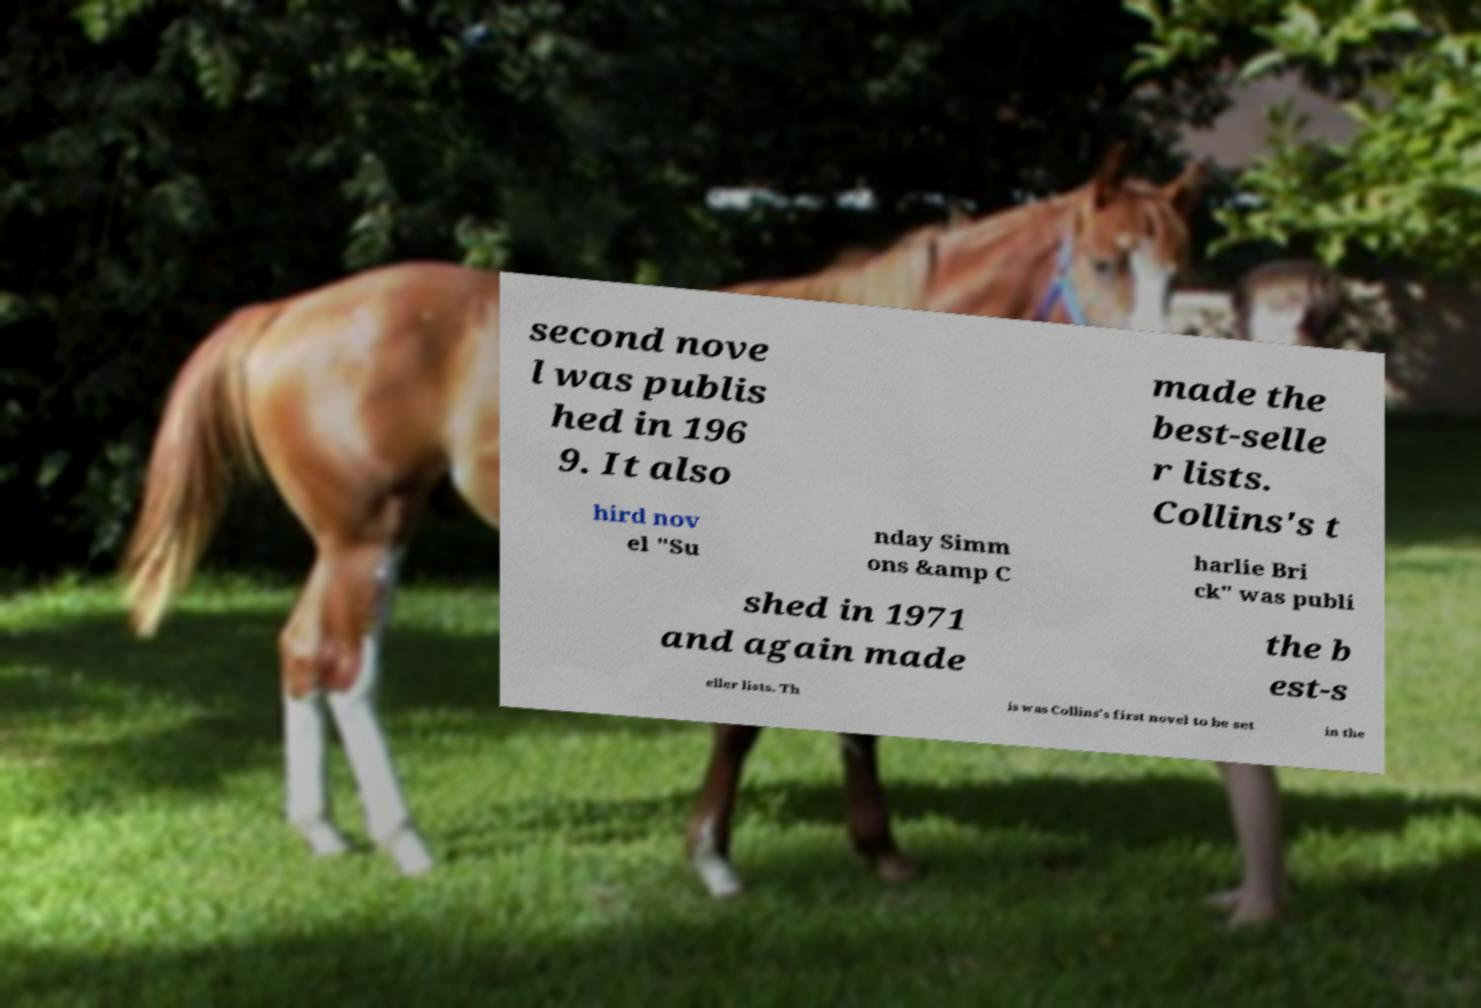Please read and relay the text visible in this image. What does it say? second nove l was publis hed in 196 9. It also made the best-selle r lists. Collins's t hird nov el "Su nday Simm ons &amp C harlie Bri ck" was publi shed in 1971 and again made the b est-s eller lists. Th is was Collins's first novel to be set in the 